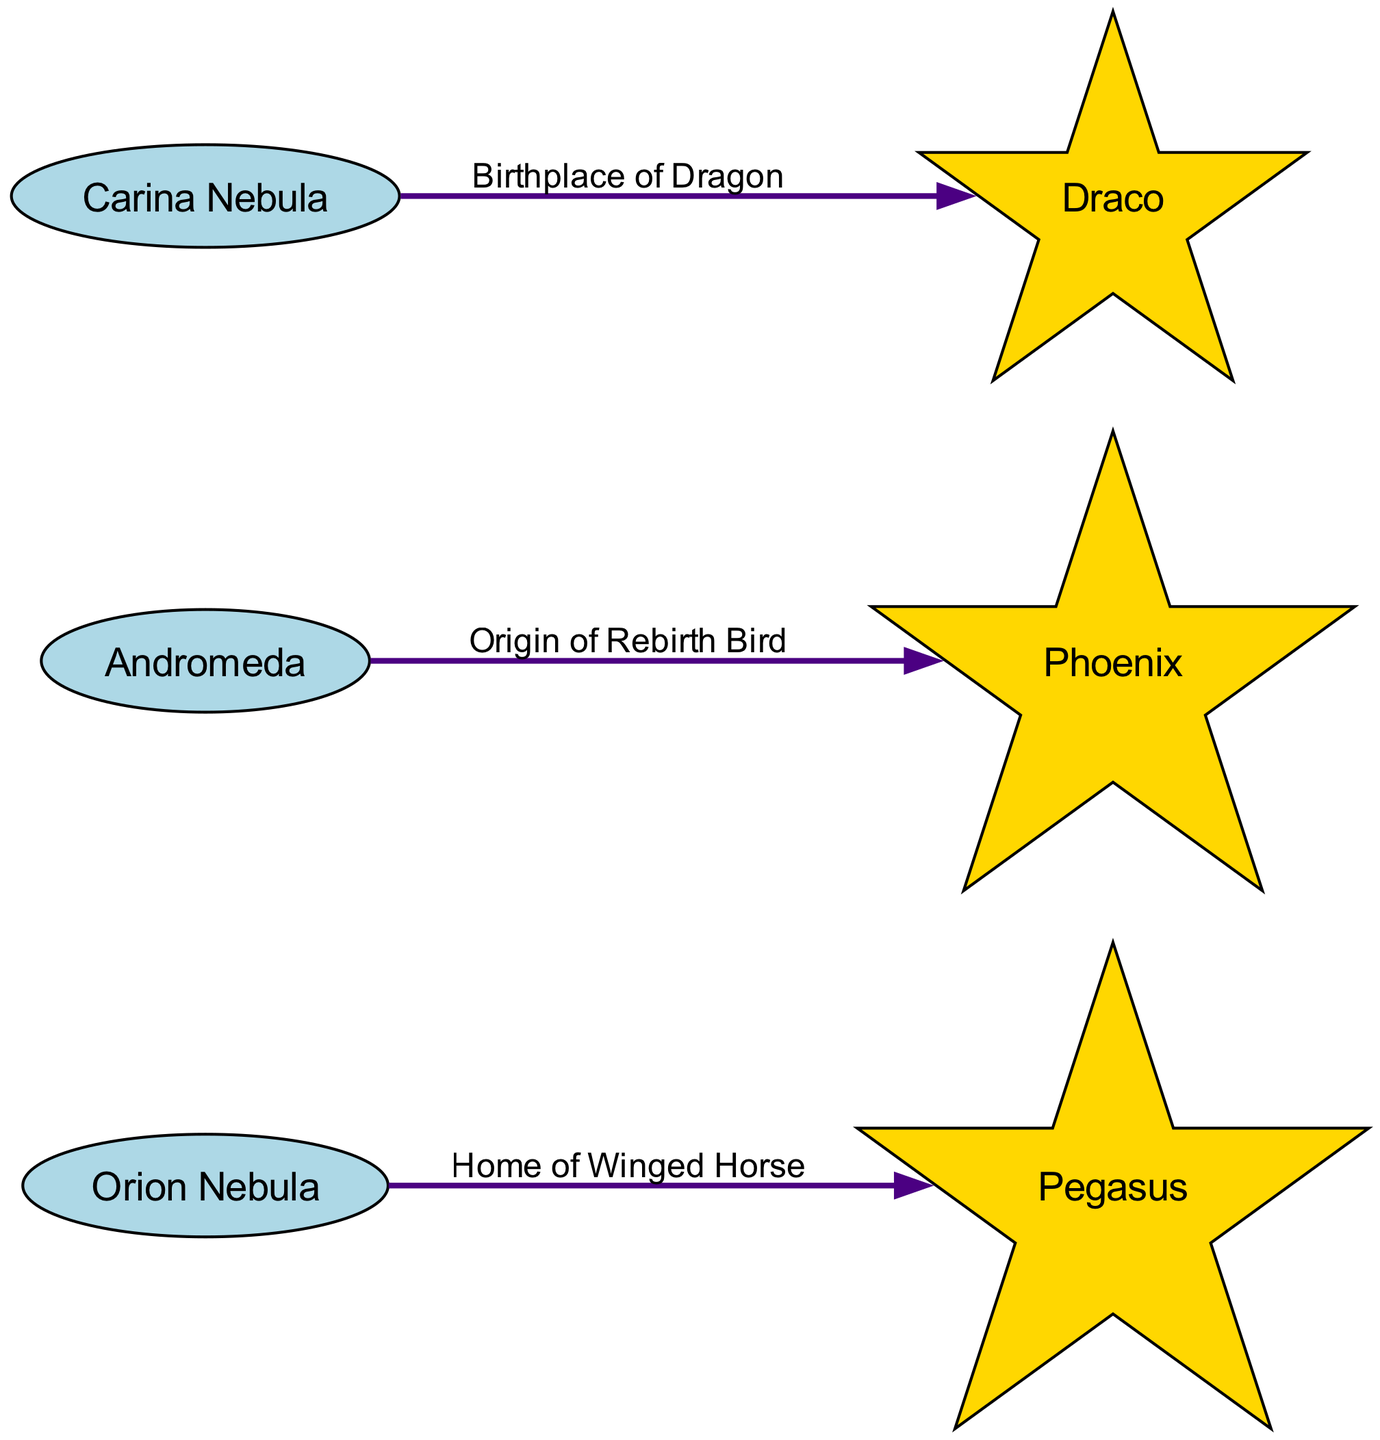What are the star-forming regions depicted in the diagram? The nodes labeled as Orion Nebula, Andromeda, and Carina Nebula represent the star-forming regions in the diagram.
Answer: Orion Nebula, Andromeda, Carina Nebula How many mythological creatures are linked to star-forming regions? There are three mythological creatures associated with the star-forming regions in the diagram: Pegasus, Phoenix, and Draco.
Answer: 3 Which star-forming region is associated with the Winged Horse? The Orion Nebula node has an edge labeled "Home of Winged Horse," indicating that it is linked to Pegasus as the associated mythological creature.
Answer: Orion Nebula What is the origin of the Rebirth Bird? The edge connecting Andromeda to Phoenix is labeled "Origin of Rebirth Bird," indicating that the mythological creature Phoenix is associated with the Andromeda region.
Answer: Andromeda Which mythological creature is the birthplace of the Dragon? The Carina Nebula is linked to Draco with the edge labeled "Birthplace of Dragon," signifying that Draco is the related mythological creature.
Answer: Carina Nebula How many edges are in the diagram? Three edges connect the star-forming regions to their respective mythological creatures, specifically Orion Nebula to Pegasus, Andromeda to Phoenix, and Carina Nebula to Draco.
Answer: 3 Which color represents the star-forming regions in the diagram? The star-forming regions are depicted in light blue, which is outlined in the code as the color assigned to these nodes.
Answer: Light Blue What does the edge color represent in the diagram? The edges that connect stars to mythological creatures are colored in dark purple, as indicated by the specified color in the code for the edges.
Answer: Dark Purple Which mythological creature is associated with the Carina Nebula? The edge labeled "Birthplace of Dragon" shows that the Carina Nebula is associated with the mythological creature Draco.
Answer: Draco 